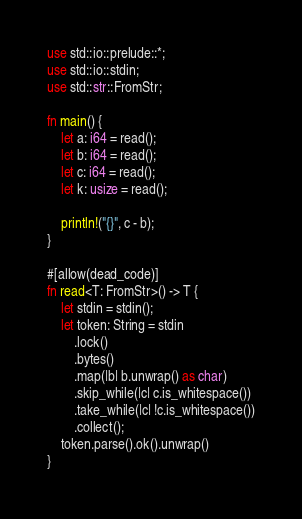Convert code to text. <code><loc_0><loc_0><loc_500><loc_500><_Rust_>use std::io::prelude::*;
use std::io::stdin;
use std::str::FromStr;

fn main() {
    let a: i64 = read();
    let b: i64 = read();
    let c: i64 = read();
    let k: usize = read();

    println!("{}", c - b);
}

#[allow(dead_code)]
fn read<T: FromStr>() -> T {
    let stdin = stdin();
    let token: String = stdin
        .lock()
        .bytes()
        .map(|b| b.unwrap() as char)
        .skip_while(|c| c.is_whitespace())
        .take_while(|c| !c.is_whitespace())
        .collect();
    token.parse().ok().unwrap()
}
</code> 